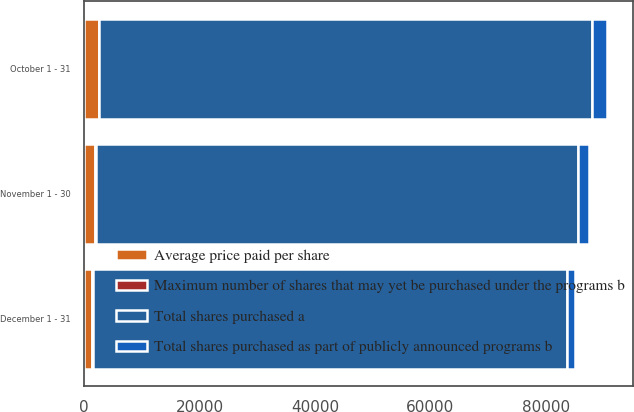Convert chart to OTSL. <chart><loc_0><loc_0><loc_500><loc_500><stacked_bar_chart><ecel><fcel>October 1 - 31<fcel>November 1 - 30<fcel>December 1 - 31<nl><fcel>Average price paid per share<fcel>2528<fcel>1923<fcel>1379<nl><fcel>Maximum number of shares that may yet be purchased under the programs b<fcel>89.24<fcel>94.06<fcel>95.2<nl><fcel>Total shares purchased as part of publicly announced programs b<fcel>2506<fcel>1923<fcel>1379<nl><fcel>Total shares purchased a<fcel>85413<fcel>83490<fcel>82111<nl></chart> 